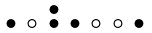Convert formula to latex. <formula><loc_0><loc_0><loc_500><loc_500>\begin{smallmatrix} & & \bullet \\ \bullet & \circ & \bullet & \bullet & \circ & \circ & \bullet & \\ \end{smallmatrix}</formula> 